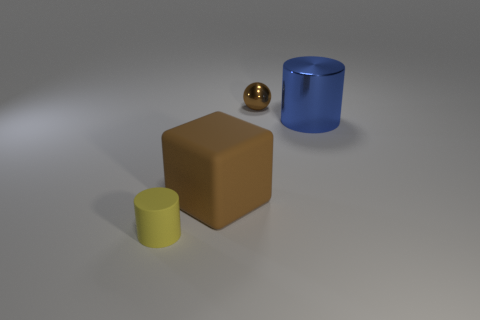Subtract 1 cylinders. How many cylinders are left? 1 Subtract all balls. How many objects are left? 3 Subtract all big yellow blocks. Subtract all large rubber blocks. How many objects are left? 3 Add 1 big metal cylinders. How many big metal cylinders are left? 2 Add 4 blue metal cubes. How many blue metal cubes exist? 4 Add 1 blue metallic cylinders. How many objects exist? 5 Subtract 0 purple cubes. How many objects are left? 4 Subtract all cyan cylinders. Subtract all yellow balls. How many cylinders are left? 2 Subtract all green cubes. How many purple cylinders are left? 0 